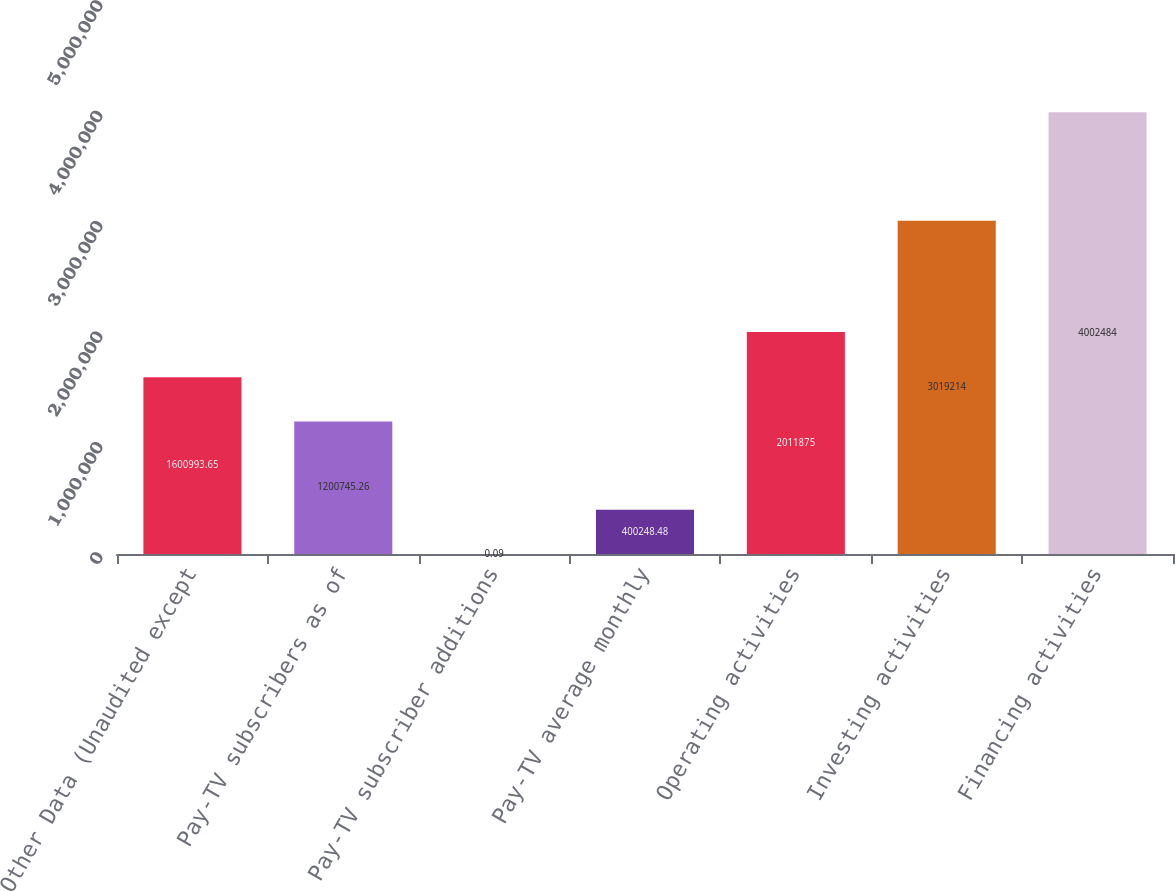Convert chart to OTSL. <chart><loc_0><loc_0><loc_500><loc_500><bar_chart><fcel>Other Data (Unaudited except<fcel>Pay-TV subscribers as of<fcel>Pay-TV subscriber additions<fcel>Pay-TV average monthly<fcel>Operating activities<fcel>Investing activities<fcel>Financing activities<nl><fcel>1.60099e+06<fcel>1.20075e+06<fcel>0.09<fcel>400248<fcel>2.01188e+06<fcel>3.01921e+06<fcel>4.00248e+06<nl></chart> 